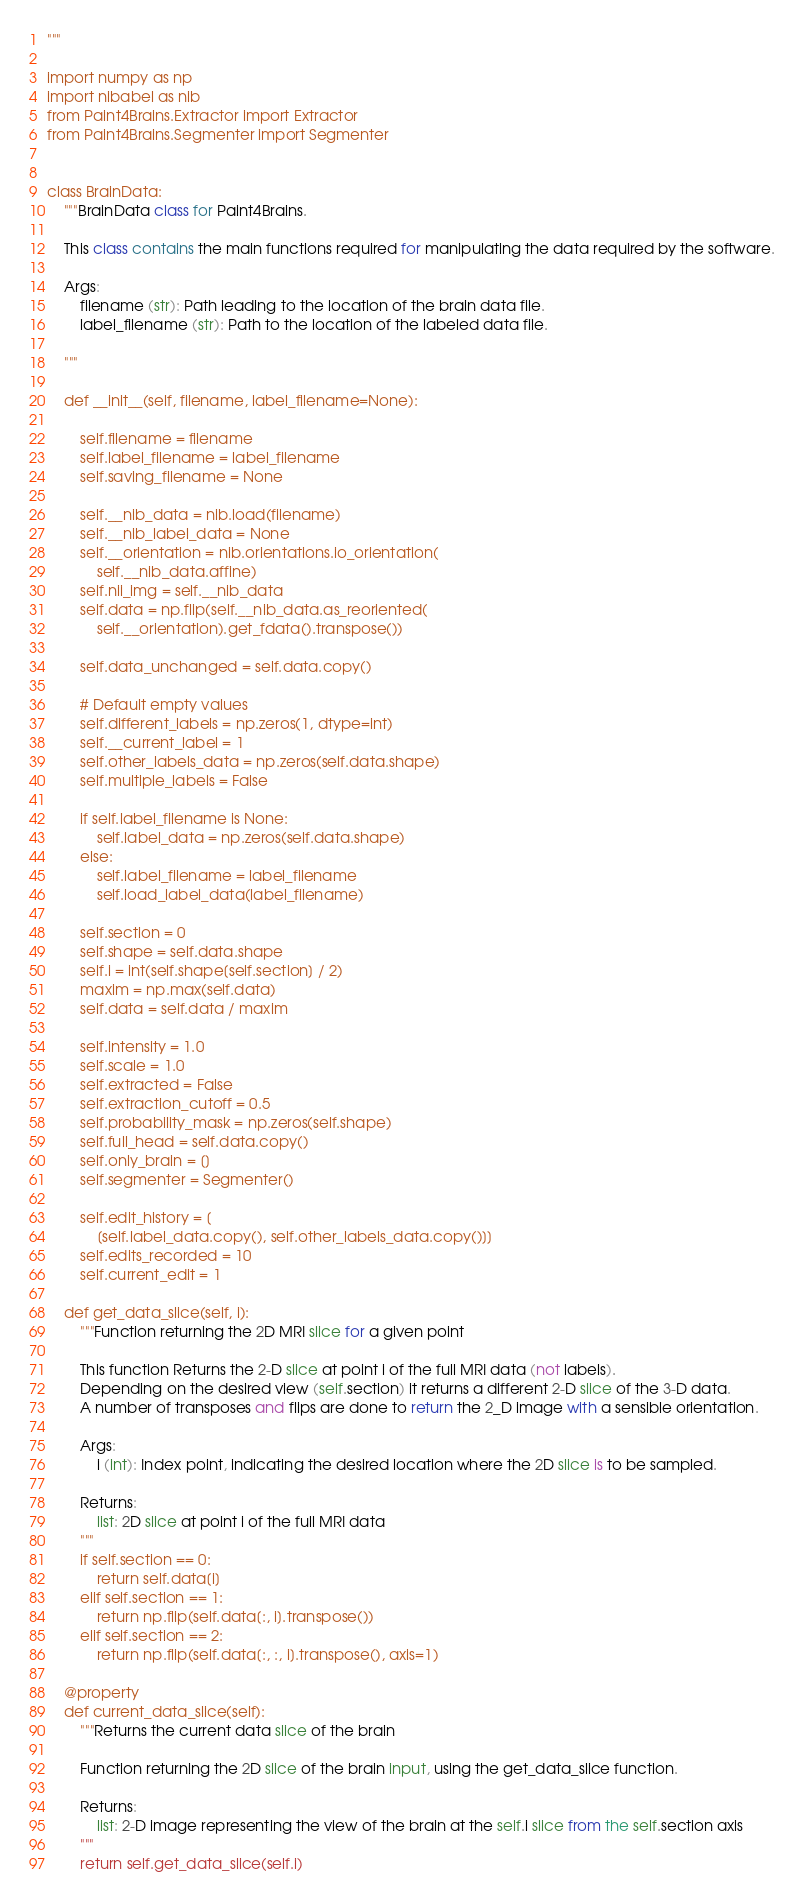Convert code to text. <code><loc_0><loc_0><loc_500><loc_500><_Python_>"""

import numpy as np
import nibabel as nib
from Paint4Brains.Extractor import Extractor
from Paint4Brains.Segmenter import Segmenter


class BrainData:
    """BrainData class for Paint4Brains.

    This class contains the main functions required for manipulating the data required by the software.

    Args:
        filename (str): Path leading to the location of the brain data file.
        label_filename (str): Path to the location of the labeled data file.

    """

    def __init__(self, filename, label_filename=None):

        self.filename = filename
        self.label_filename = label_filename
        self.saving_filename = None

        self.__nib_data = nib.load(filename)
        self.__nib_label_data = None
        self.__orientation = nib.orientations.io_orientation(
            self.__nib_data.affine)
        self.nii_img = self.__nib_data
        self.data = np.flip(self.__nib_data.as_reoriented(
            self.__orientation).get_fdata().transpose())

        self.data_unchanged = self.data.copy()

        # Default empty values
        self.different_labels = np.zeros(1, dtype=int)
        self.__current_label = 1
        self.other_labels_data = np.zeros(self.data.shape)
        self.multiple_labels = False

        if self.label_filename is None:
            self.label_data = np.zeros(self.data.shape)
        else:
            self.label_filename = label_filename
            self.load_label_data(label_filename)

        self.section = 0
        self.shape = self.data.shape
        self.i = int(self.shape[self.section] / 2)
        maxim = np.max(self.data)
        self.data = self.data / maxim

        self.intensity = 1.0
        self.scale = 1.0
        self.extracted = False
        self.extraction_cutoff = 0.5
        self.probability_mask = np.zeros(self.shape)
        self.full_head = self.data.copy()
        self.only_brain = []
        self.segmenter = Segmenter()

        self.edit_history = [
            [self.label_data.copy(), self.other_labels_data.copy()]]
        self.edits_recorded = 10
        self.current_edit = 1

    def get_data_slice(self, i):
        """Function returning the 2D MRI slice for a given point

        This function Returns the 2-D slice at point i of the full MRI data (not labels).
        Depending on the desired view (self.section) it returns a different 2-D slice of the 3-D data.
        A number of transposes and flips are done to return the 2_D image with a sensible orientation.

        Args:
            i (int): Index point, indicating the desired location where the 2D slice is to be sampled.

        Returns:
            list: 2D slice at point i of the full MRI data
        """
        if self.section == 0:
            return self.data[i]
        elif self.section == 1:
            return np.flip(self.data[:, i].transpose())
        elif self.section == 2:
            return np.flip(self.data[:, :, i].transpose(), axis=1)

    @property
    def current_data_slice(self):
        """Returns the current data slice of the brain

        Function returning the 2D slice of the brain input, using the get_data_slice function.

        Returns:
            list: 2-D image representing the view of the brain at the self.i slice from the self.section axis
        """
        return self.get_data_slice(self.i)
</code> 